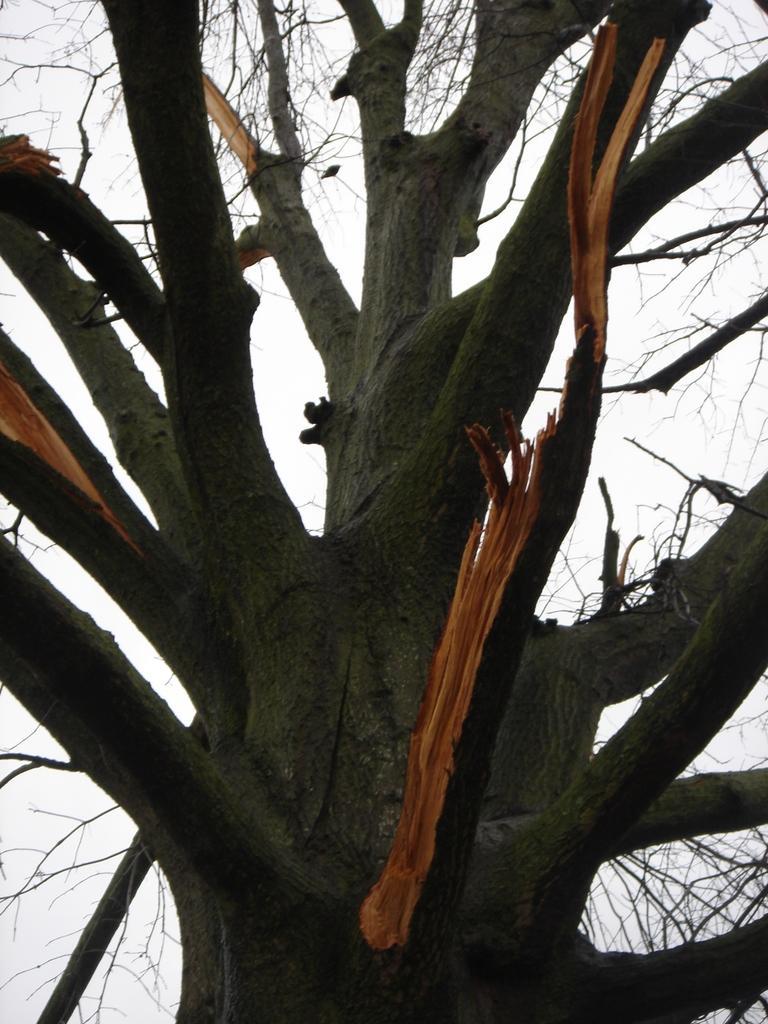Please provide a concise description of this image. In the picture I can see the tree trunk with its branches and in the background, I can see the sky. 